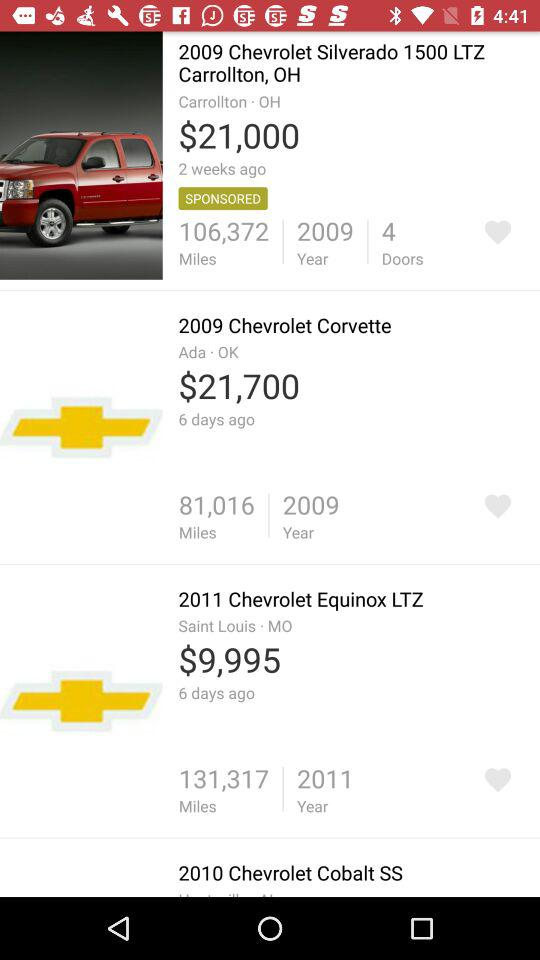What is the model of the car? The models of the cars are the Silverado 1500 LTZ, Corvette, Equinox LTZ and Cobalt SS. 